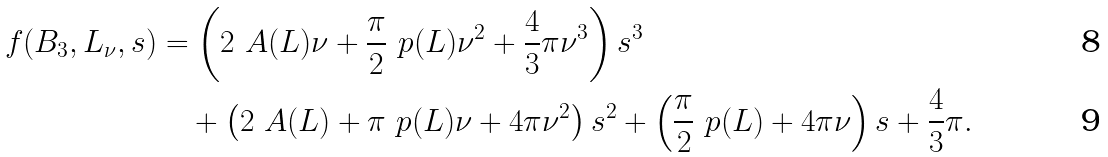<formula> <loc_0><loc_0><loc_500><loc_500>f ( B _ { 3 } , L _ { \nu } , s ) & = \left ( 2 \ A ( L ) \nu + \frac { \pi } { 2 } \ p ( L ) \nu ^ { 2 } + \frac { 4 } { 3 } \pi \nu ^ { 3 } \right ) s ^ { 3 } \\ & \quad + \left ( 2 \ A ( L ) + \pi \ p ( L ) \nu + 4 \pi \nu ^ { 2 } \right ) s ^ { 2 } + \left ( \frac { \pi } { 2 } \ p ( L ) + 4 \pi \nu \right ) s + \frac { 4 } { 3 } \pi .</formula> 